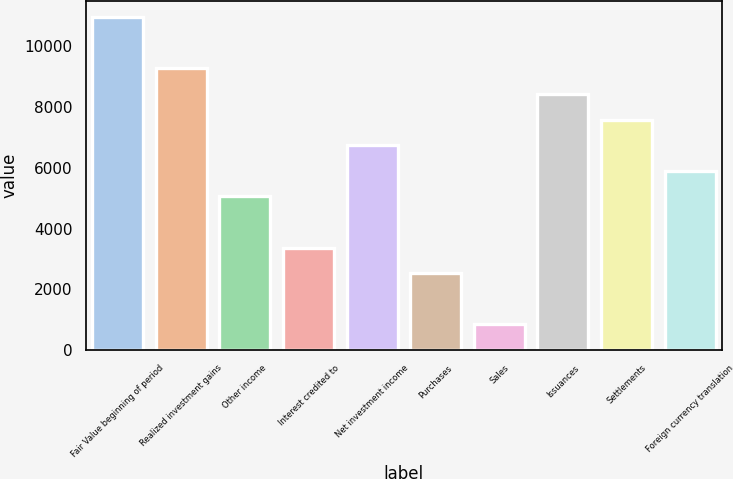Convert chart to OTSL. <chart><loc_0><loc_0><loc_500><loc_500><bar_chart><fcel>Fair Value beginning of period<fcel>Realized investment gains<fcel>Other income<fcel>Interest credited to<fcel>Net investment income<fcel>Purchases<fcel>Sales<fcel>Issuances<fcel>Settlements<fcel>Foreign currency translation<nl><fcel>10963.8<fcel>9277.27<fcel>5060.87<fcel>3374.31<fcel>6747.43<fcel>2531.03<fcel>844.47<fcel>8433.99<fcel>7590.71<fcel>5904.15<nl></chart> 